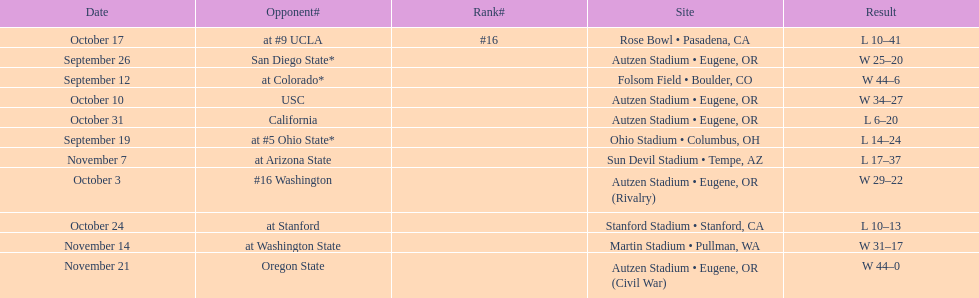How many games did the team win while not at home? 2. 